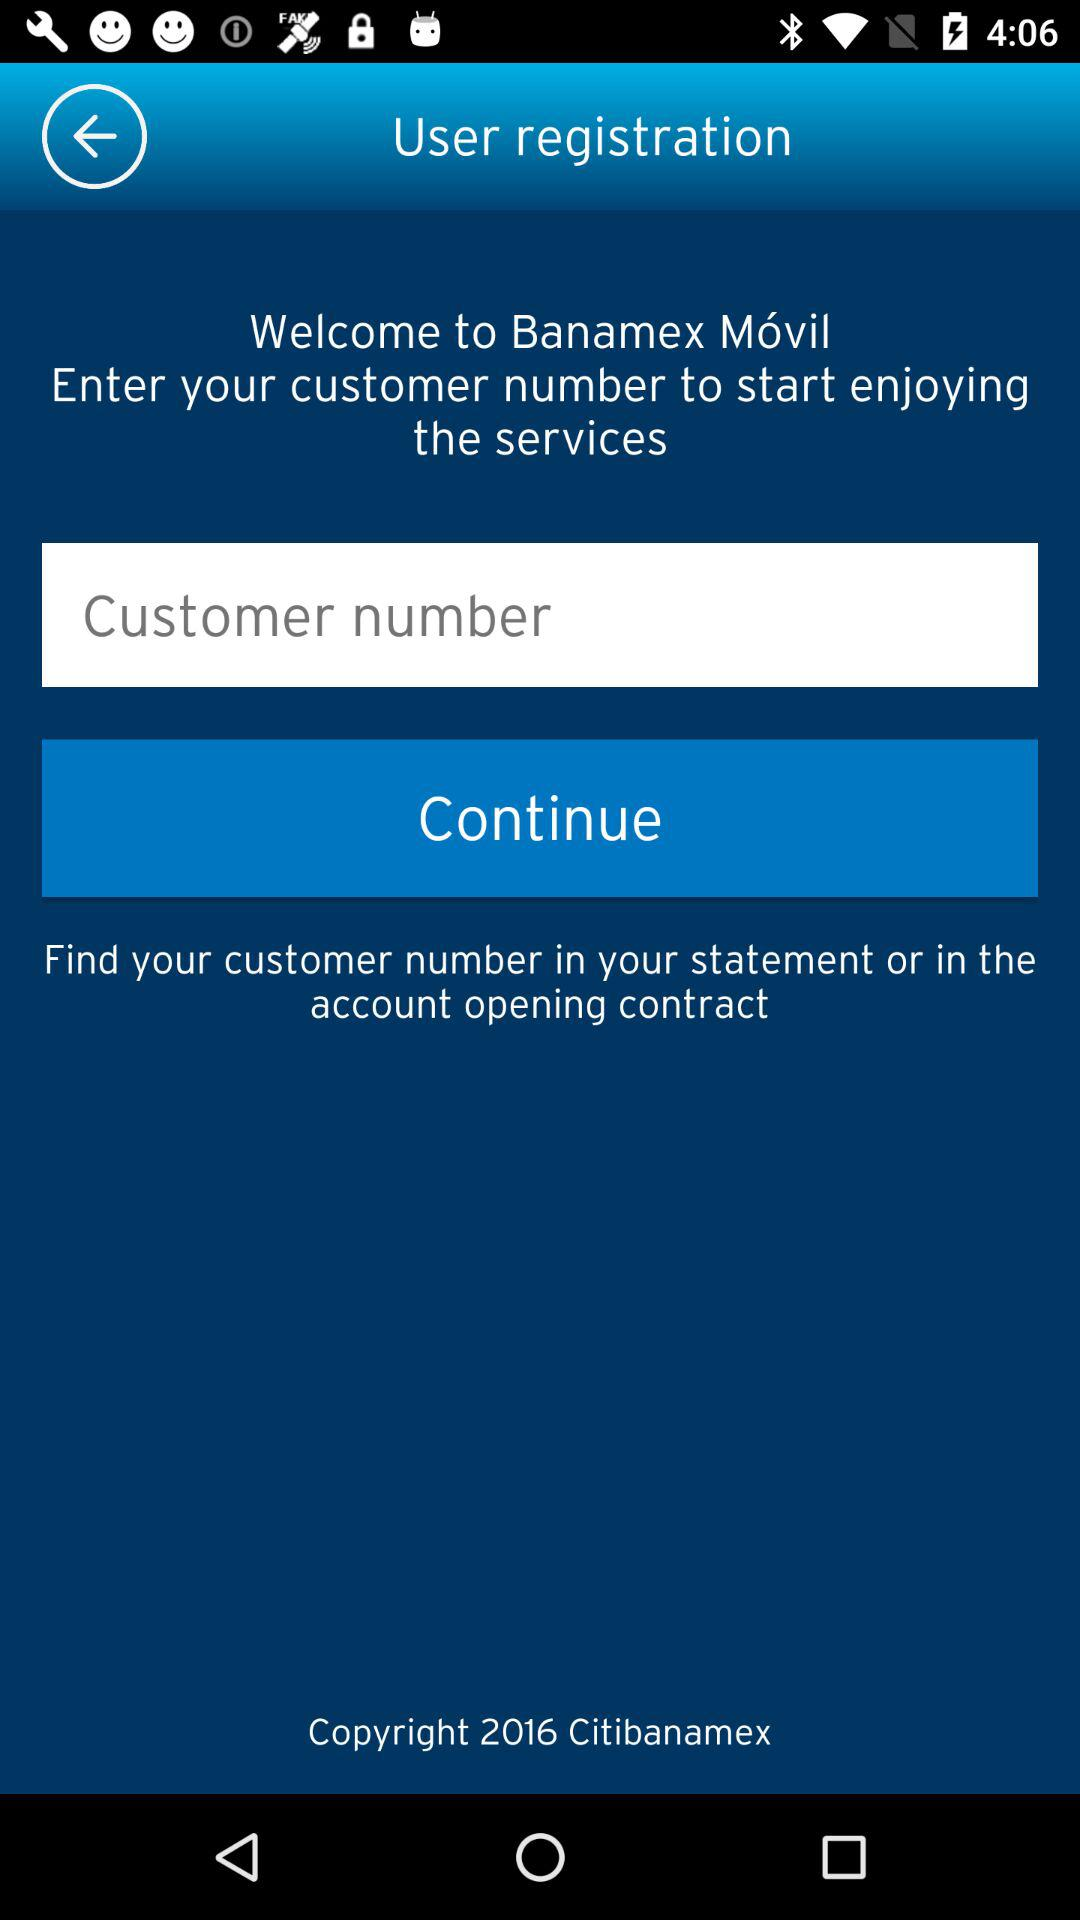What is the customer number?
When the provided information is insufficient, respond with <no answer>. <no answer> 